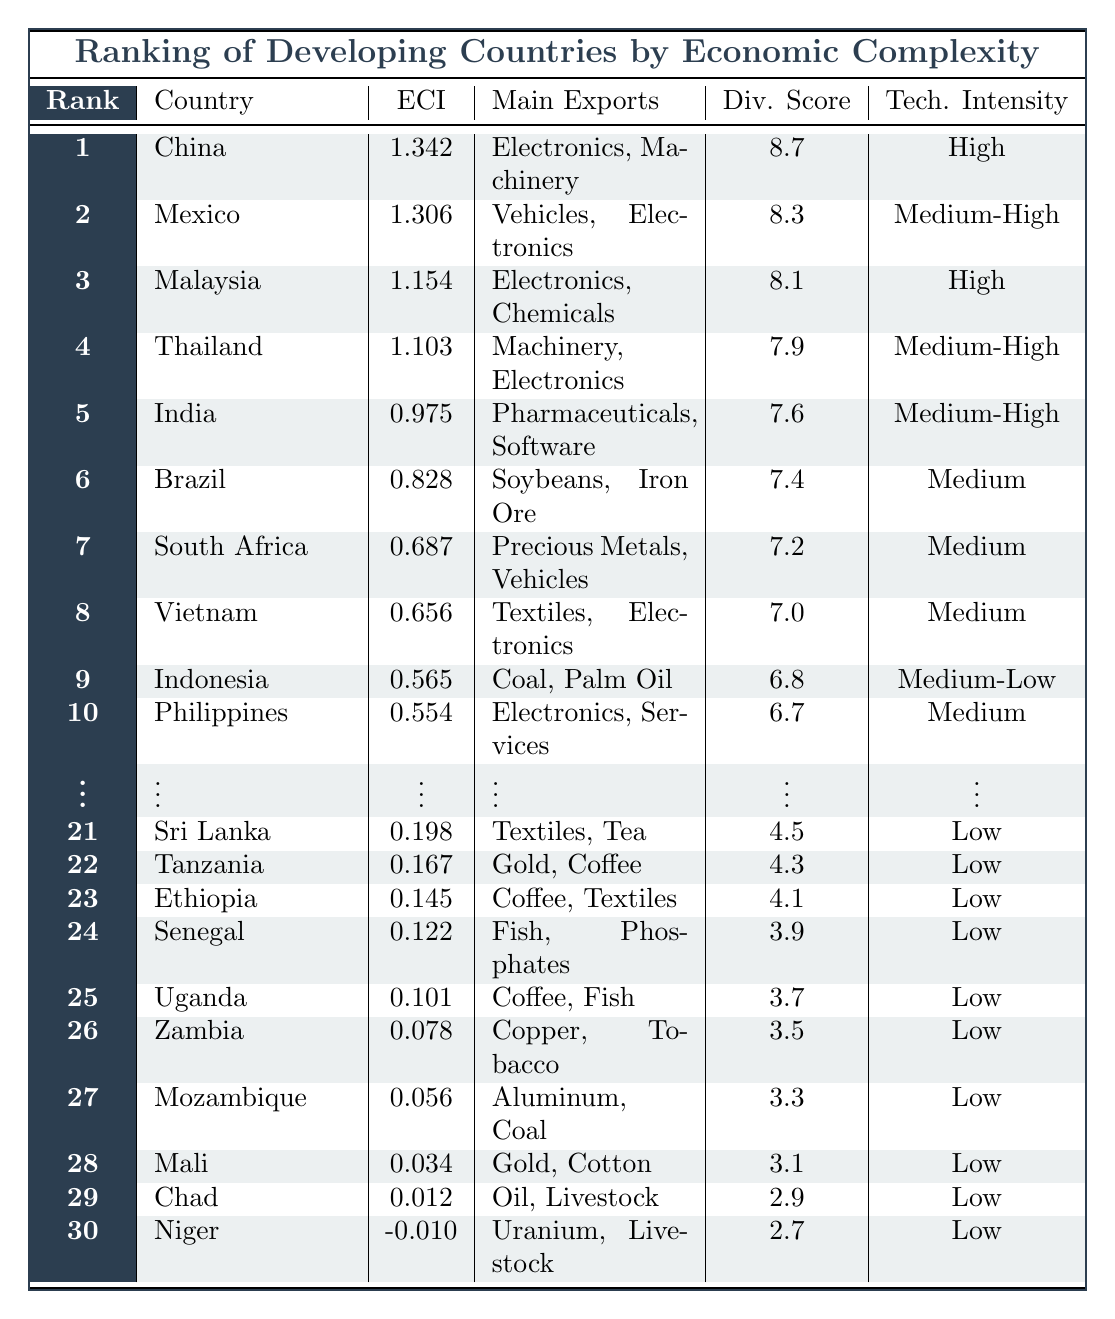What is the Economic Complexity Index score of Brazil? Brazil's Economic Complexity Index score is found in the table under the corresponding row for Brazil, which shows the value as 0.828.
Answer: 0.828 Which country has the highest Diversification Score? The Diversification Scores are compared; China has the highest score listed at 8.7, listed in the first row of the table.
Answer: 8.7 Is the Technology Intensity for Indonesia classified as Medium or Medium-Low? Looking at the table, Indonesia's Technology Intensity is specifically labeled as Medium-Low in the corresponding row.
Answer: Medium-Low How many countries have an Economic Complexity Index score greater than 1? To find this, I count the number of countries with scores over 1 shown in the table. Those countries are China (1.342), Mexico (1.306), Malaysia (1.154), and Thailand (1.103), resulting in a total of 4 countries.
Answer: 4 What is the average Economic Complexity Index score for the top 5 countries? I sum the Economic Complexity Index scores of the top 5 countries: 1.342 (China) + 1.306 (Mexico) + 1.154 (Malaysia) + 1.103 (Thailand) + 0.975 (India) = 5.88. Then, I divide by 5 to find the average: 5.88 / 5 = 1.176.
Answer: 1.176 Which country ranks 15th and what is its main export? The 15th country in the ranking is Egypt. The main export listed for Egypt in the table is Oil and Textiles.
Answer: Egypt; Oil, Textiles Is the Economic Complexity Index score for Niger positive? The score for Niger is presented in the table as -0.010, which indicates it is not positive but rather negative.
Answer: No What is the relationship between Economic Complexity Index scores and Technology Intensity for the top 3 countries? By examining the table, the top 3 countries (China, Mexico, Malaysia) all have high Economic Complexity Index scores alongside their Technology Intensity being high or medium-high, showing a positive relationship.
Answer: Positive relationship How does the Diversification Score of South Africa compare to that of Vietnam? The table indicates South Africa has a Diversification Score of 7.2, while Vietnam has a score of 7.0, showing that South Africa's score is higher by 0.2.
Answer: South Africa is higher by 0.2 Count how many countries have a Diversification Score below 4.0. By inspecting the table, I count the countries with a Diversification Score below 4.0, which are Senegal (3.9), Uganda (3.7), Zambia (3.5), Mozambique (3.3), Mali (3.1), Chad (2.9), and Niger (2.7). This totals to 7 countries.
Answer: 7 